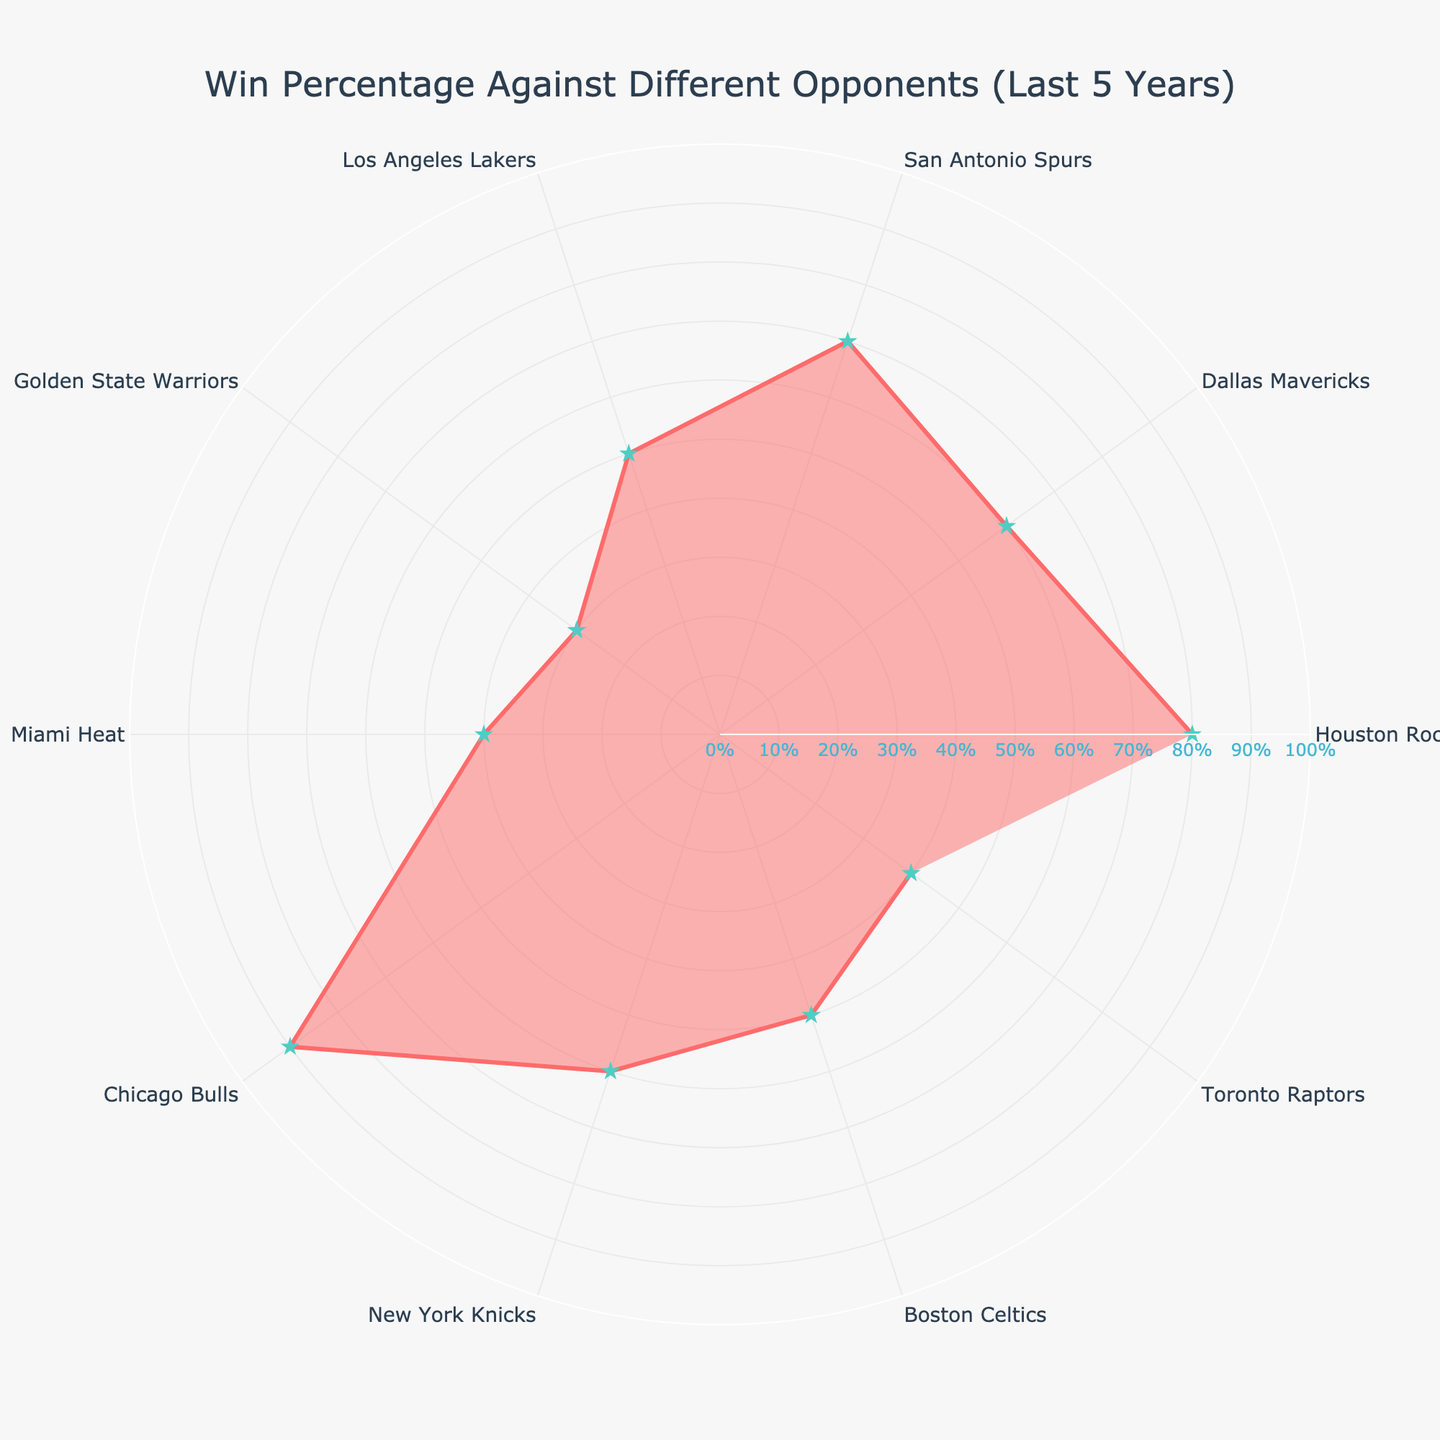What's the title of the chart? The title is clearly mentioned at the top of the chart. It helps in understanding the overall context of what the chart is representing.
Answer: Win Percentage Against Different Opponents (Last 5 Years) Which opponent has the highest win percentage? By examining the chart, the radial distance for the 'Chicago Bulls' is the largest, indicating the highest win percentage.
Answer: Chicago Bulls Which opponent has an equal number of wins and losses? Identify the points where the win percentage is 50%; both 'Los Angeles Lakers' and 'Boston Celtics' have data points at this position.
Answer: Los Angeles Lakers, Boston Celtics What is the win percentage against the Golden State Warriors? Look for the radial distance corresponding to 'Golden State Warriors' on the chart to determine its position in percentage.
Answer: 30% How many opponents have a win percentage greater than 50%? Locate all data points with a radial distance greater than the halfway mark (50%). They include Houston Rockets, Dallas Mavericks, San Antonio Spurs, Chicago Bulls, and New York Knicks.
Answer: Five What's the average win percentage across all opponents? Sum all the win percentages and then divide by the number of opponents. \( ((80 + 60 + 70 + 50 + 30 + 40 + 90 + 60 + 50 + 40) / 10 = 57) \).
Answer: 57% Compare the win percentage against Miami Heat and Toronto Raptors. Which is higher? Observe both radial points to see which extends further from the center; 'Miami Heat' and 'Toronto Raptors' both show 40%.
Answer: They are equal Which opponent has the lowest win percentage? The shortest radial distance from the center represents the lowest percentage, which belongs to the 'Golden State Warriors'.
Answer: Golden State Warriors What’s the combined win percentage against Texas teams (Houston Rockets, Dallas Mavericks, San Antonio Spurs)? Add the win percentages of the Texas teams: \( 80 + 60 + 70 = 210 \).
Answer: 210% What is the difference in win percentage between the New York Knicks and the Boston Celtics? Subtract Boston Celtics' win percentage from the New York Knicks' win percentage \((60 - 50 = 10)\).
Answer: 10% 